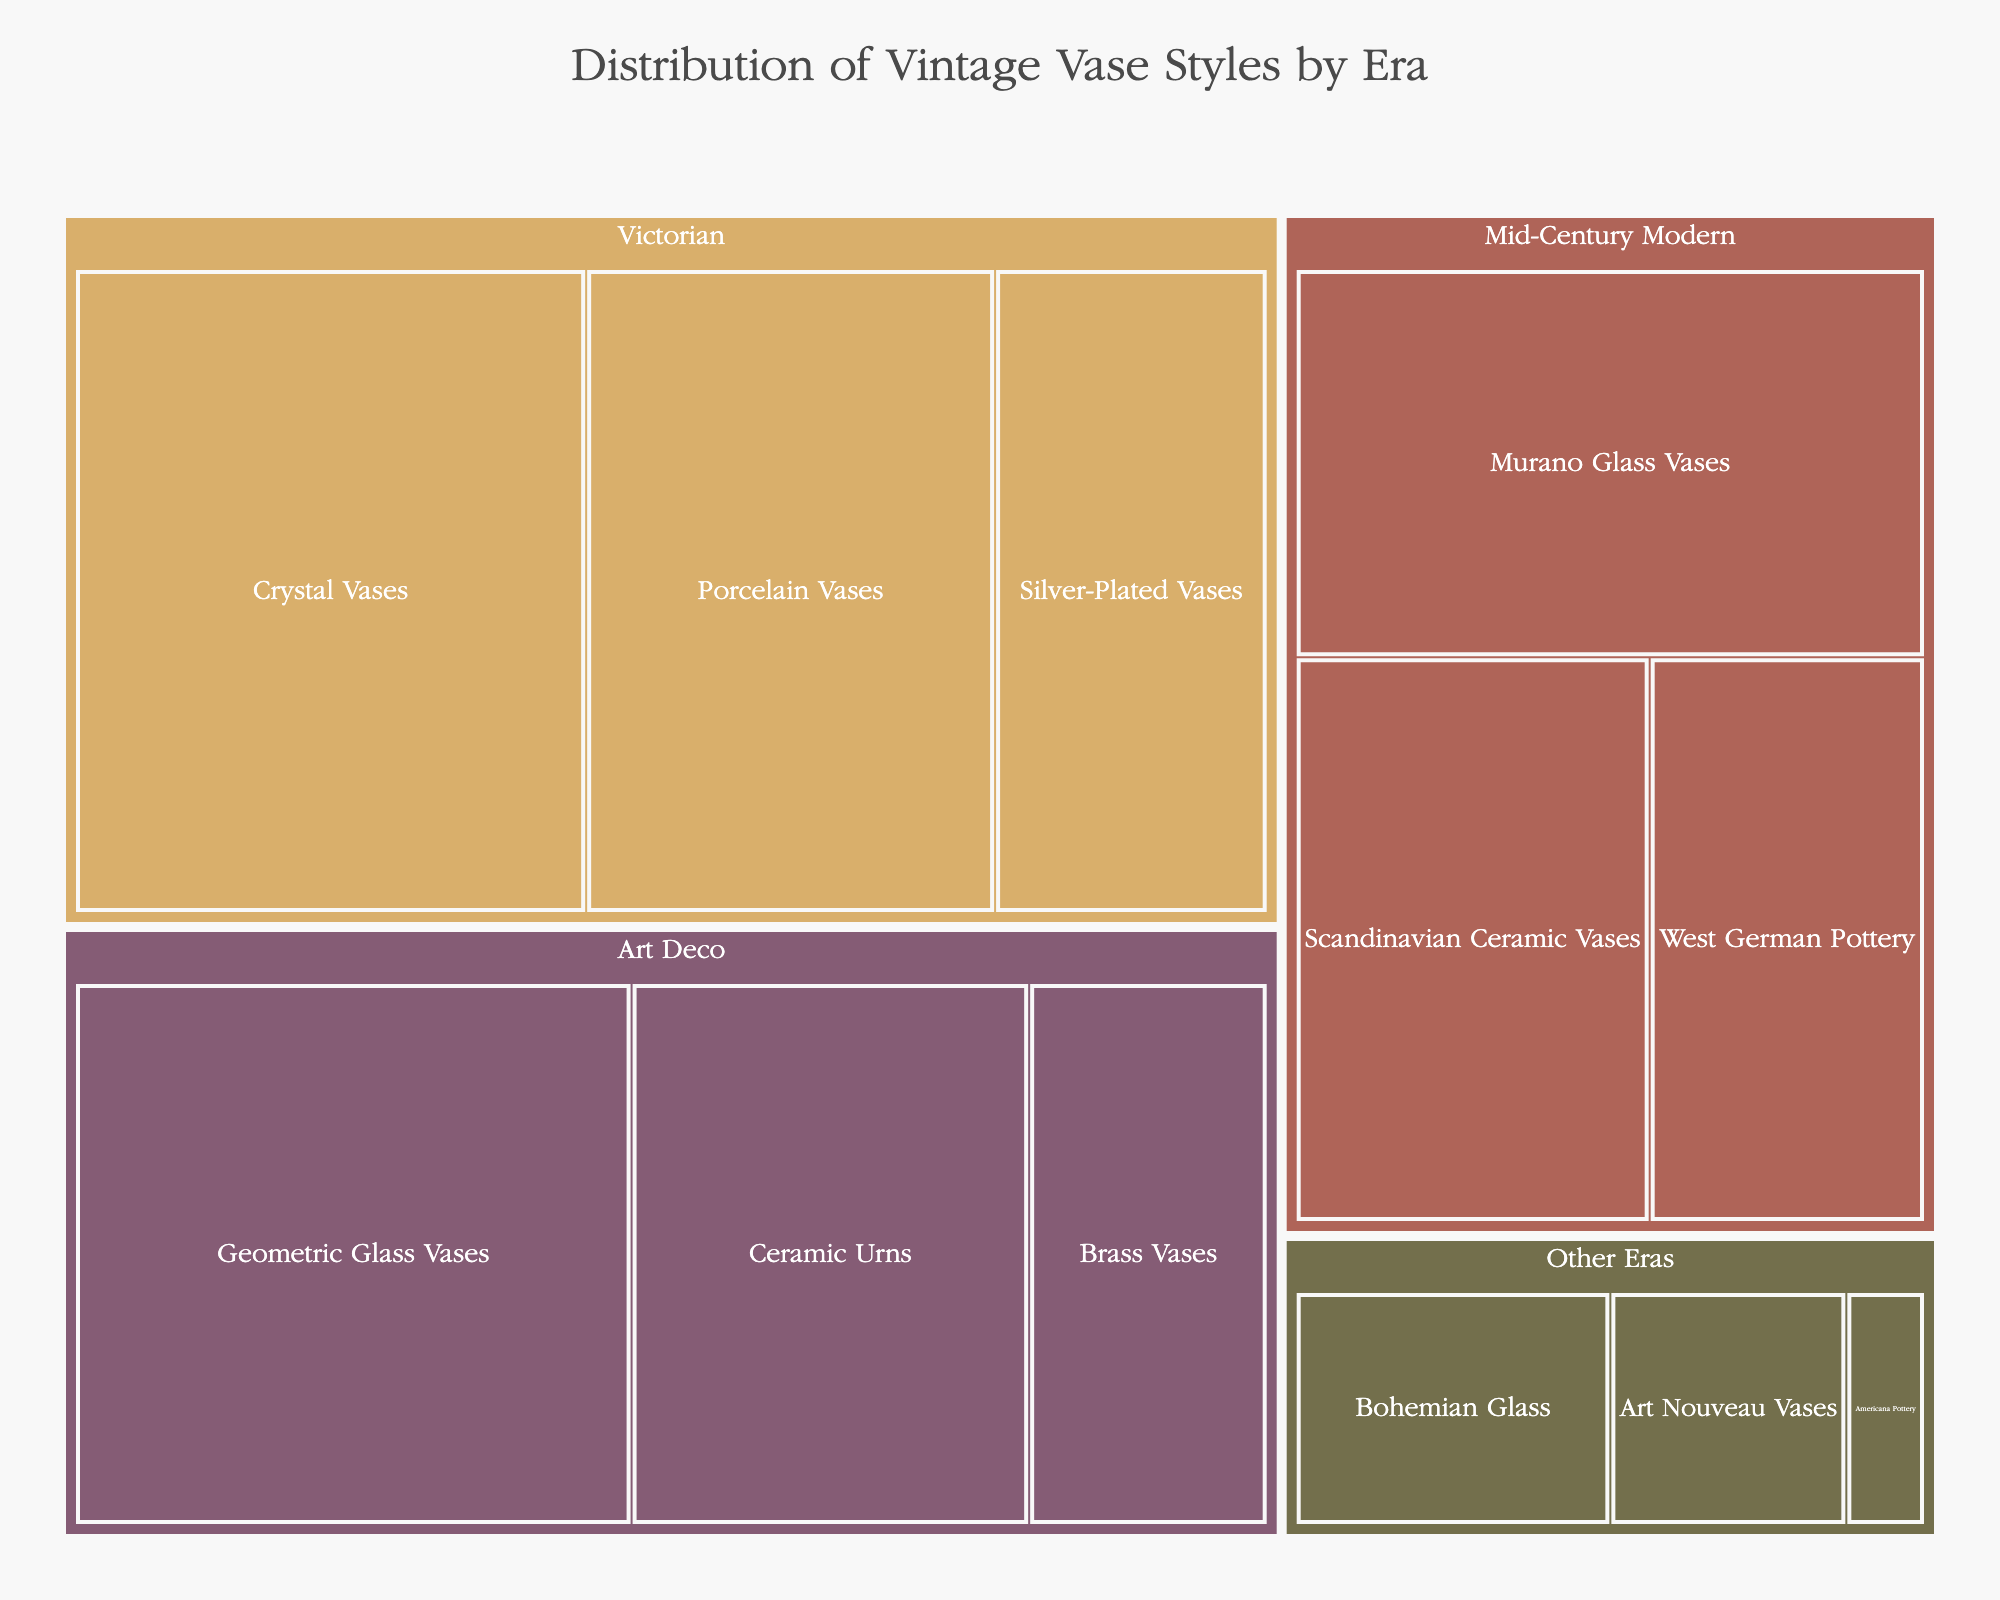Which era has the highest percentage of vintage vase styles? By observing the treemap, the Victorian era occupies the largest portion of the chart, indicating it has the highest percentage.
Answer: Victorian What is the percentage of Mid-Century Modern vase styles in total? Sum the percentages of all styles under Mid-Century Modern: Murano Glass Vases (11%) + Scandinavian Ceramic Vases (9%) + West German Pottery (7%) = 27%.
Answer: 27% Which era contains styles with the smallest percentages? The collected data for "Other Eras" shows the smallest individual percentages with Bohemian Glass (4%), Art Nouveau Vases (3%), and Americana Pottery (1%).
Answer: Other Eras Compare the total percentage of Art Deco vase styles to Victorian vase styles. Which is higher and by how much? Sum Art Deco styles: Geometric Glass Vases (14%) + Ceramic Urns (10%) + Brass Vases (6%) = 30%. Sum Victorian styles: Crystal Vases (15%) + Porcelain Vases (12%) + Silver-Plated Vases (8%) = 35%. Victorian is higher by 5%.
Answer: Victorian is higher by 5% What style has the highest percentage within the Victorian era? Within the Victorian era, Crystal Vases have the highest percentage at 15%.
Answer: Crystal Vases How do the percentages of Geometric Glass Vases and Murano Glass Vases compare? Geometric Glass Vases (14%) is greater than Murano Glass Vases (11%).
Answer: Geometric Glass Vases is greater Among the Art Deco styles, which one has the lowest percentage? Within the Art Deco era, Brass Vases have the lowest percentage at 6%.
Answer: Brass Vases Considering all styles from the data, what is the least common vintage vase style by percentage? Americana Pottery under "Other Eras" has the lowest percentage at 1%.
Answer: Americana Pottery If you combine the percentages of Ceramic Urns and Scandinavian Ceramic Vases, what fraction of the total do they make up? Ceramic Urns (10%) + Scandinavian Ceramic Vases (9%) = 19%.
Answer: 19% Which era has more diverse vase styles, Art Deco or Mid-Century Modern, and how many styles does each contain? Both Art Deco and Mid-Century Modern eras have an equal number of vase styles. Each contains three different styles.
Answer: Both have three styles 